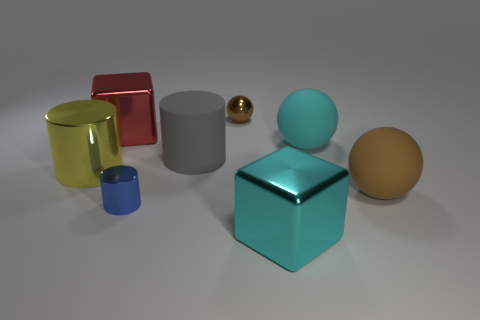There is a brown object behind the large cylinder on the right side of the red cube; what is its size? The brown object appears to be a sphere and is relatively small when compared to the larger objects in the image, such as the cylinders and cubes. Its dimensions are not the smallest in the scene, as it is larger than the mini cylinder and the small golden ball. 